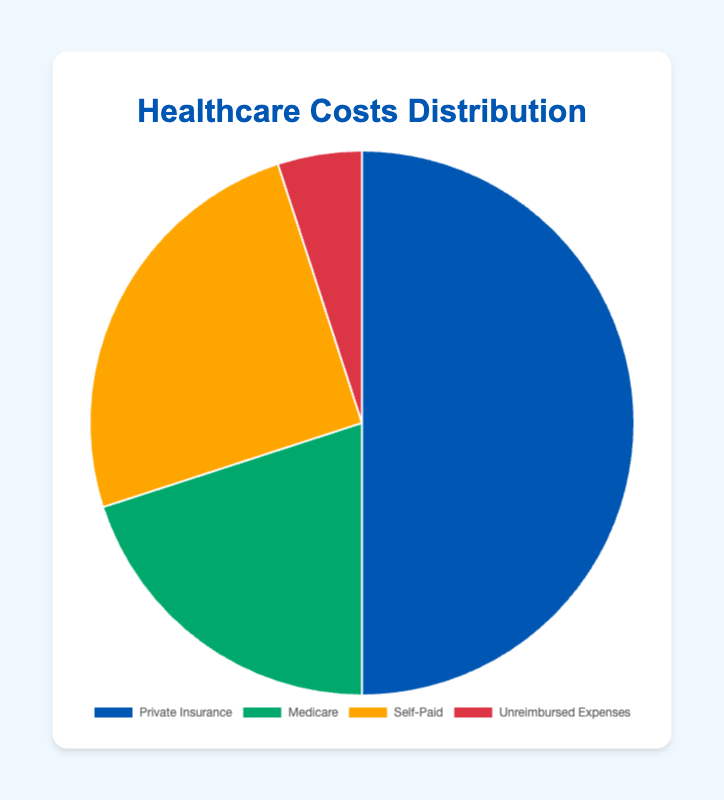Which coverage option accounts for the largest proportion of healthcare costs? Private Insurance covers the largest proportion of healthcare costs. This can be seen because Private Insurance has the largest slice of the pie, taking up 50% of the total healthcare costs.
Answer: Private Insurance What is the combined proportion of healthcare costs covered by Medicare and Private Insurance? To find the combined proportion, add the percentages for Medicare and Private Insurance. Medicare covers 20% and Private Insurance covers 50%, so the combined proportion is 20% + 50% = 70%.
Answer: 70% How does the proportion of Self-Paid costs compare to the costs covered by Medicare? Compare the percentages: Self-Paid is 25% and Medicare is 20%. Since 25% is greater than 20%, the Self-Paid costs are higher than those covered by Medicare.
Answer: Self-Paid is higher Which category covers more healthcare costs, Insurance Coverage or Out-of-Pocket? Sum the proportions within each category. Insurance Coverage includes Private Insurance (50%) and Medicare (20%): 50% + 20% = 70%. Out-of-Pocket includes Self-Paid (25%) and Unreimbursed Expenses (5%): 25% + 5% = 30%. Insurance Coverage covers more at 70%.
Answer: Insurance Coverage What is the difference in the proportion of healthcare costs between Self-Paid and Unreimbursed Expenses? Subtract the proportion of Unreimbursed Expenses from Self-Paid: 25% - 5% = 20%.
Answer: 20% If you were to combine the costs covered by Private Insurance, Medicare, and Self-Paid, what proportion of healthcare costs would remain for Unreimbursed Expenses? First, sum the proportions of Private Insurance, Medicare, and Self-Paid: 50% + 20% + 25% = 95%. The remaining proportion for Unreimbursed Expenses would be 100% - 95% = 5%.
Answer: 5% What color represents the costs covered by Medicare in the pie chart? Look at the visual representation of the pie chart, Medicare is represented by the green section.
Answer: Green Is the combined proportion of Out-of-Pocket expenses greater or less than any single Insurance Coverage source? Combine the Out-of-Pocket expenses: Self-Paid (25%) + Unreimbursed Expenses (5%) = 30%. Compare this with Private Insurance (50%) and Medicare (20%). 30% is less than 50% (Private Insurance) but greater than 20% (Medicare).
Answer: Greater than Medicare, less than Private Insurance 